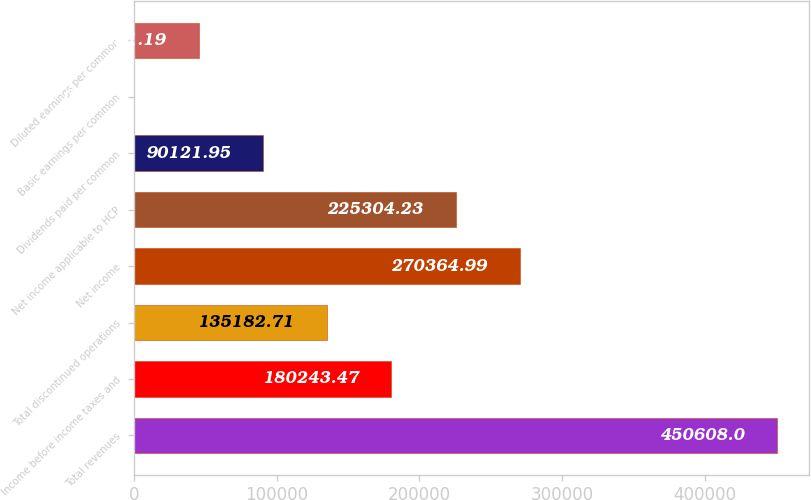Convert chart to OTSL. <chart><loc_0><loc_0><loc_500><loc_500><bar_chart><fcel>Total revenues<fcel>Income before income taxes and<fcel>Total discontinued operations<fcel>Net income<fcel>Net income applicable to HCP<fcel>Dividends paid per common<fcel>Basic earnings per common<fcel>Diluted earnings per common<nl><fcel>450608<fcel>180243<fcel>135183<fcel>270365<fcel>225304<fcel>90121.9<fcel>0.43<fcel>45061.2<nl></chart> 